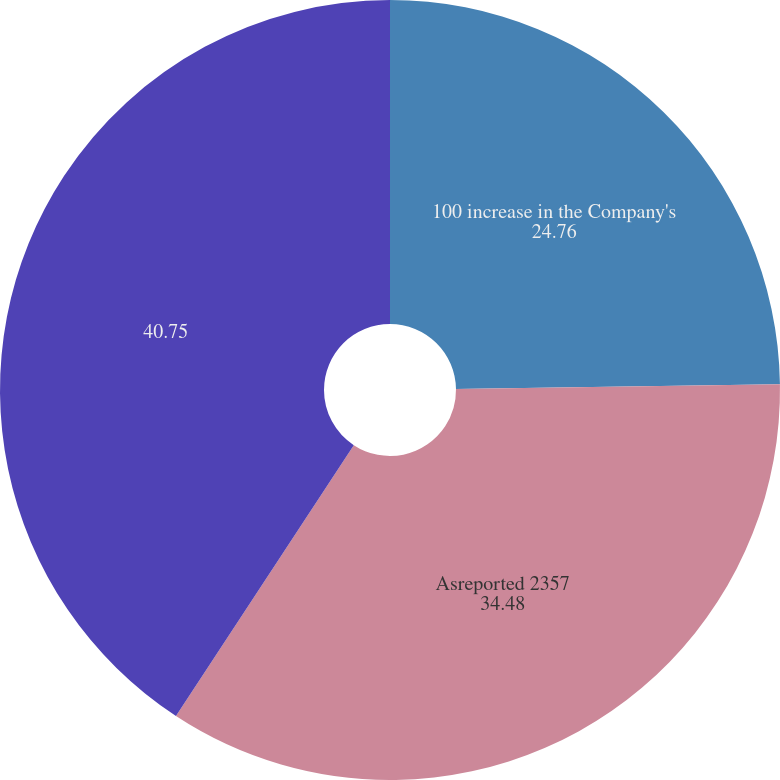Convert chart to OTSL. <chart><loc_0><loc_0><loc_500><loc_500><pie_chart><fcel>100 increase in the Company's<fcel>Asreported 2357<fcel>Unnamed: 2<nl><fcel>24.76%<fcel>34.48%<fcel>40.75%<nl></chart> 